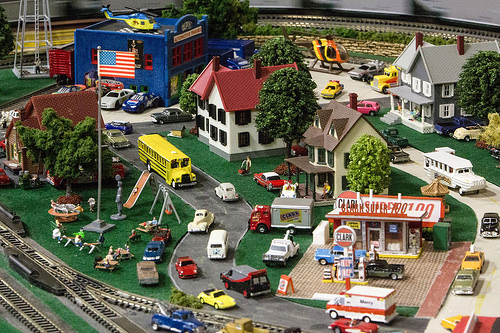<image>
Is the white car to the left of the red car? Yes. From this viewpoint, the white car is positioned to the left side relative to the red car. Where is the helicopter in relation to the car? Is it above the car? Yes. The helicopter is positioned above the car in the vertical space, higher up in the scene. 